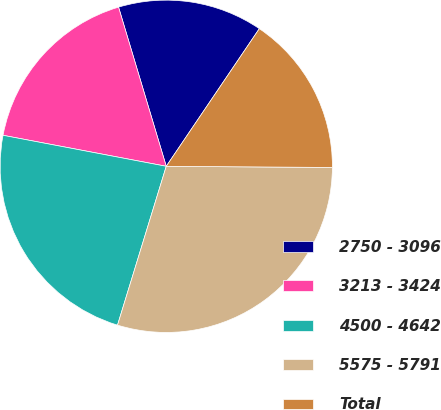<chart> <loc_0><loc_0><loc_500><loc_500><pie_chart><fcel>2750 - 3096<fcel>3213 - 3424<fcel>4500 - 4642<fcel>5575 - 5791<fcel>Total<nl><fcel>14.1%<fcel>17.38%<fcel>23.25%<fcel>29.63%<fcel>15.65%<nl></chart> 